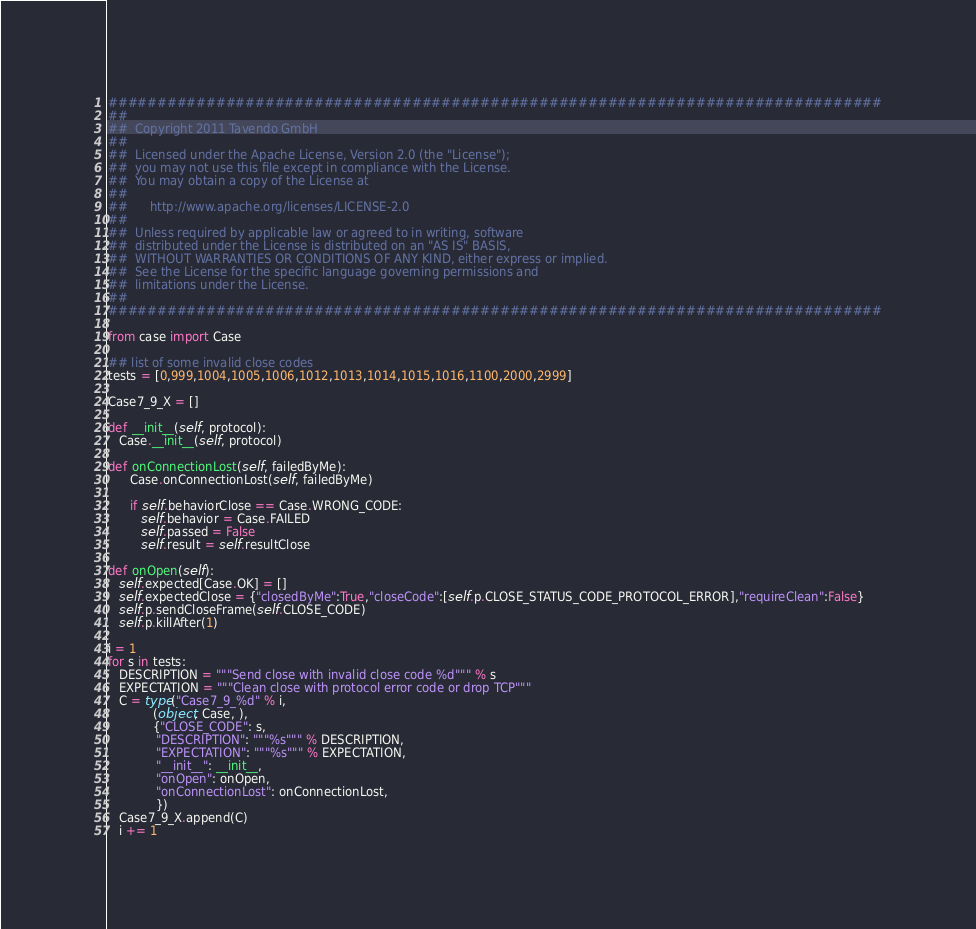Convert code to text. <code><loc_0><loc_0><loc_500><loc_500><_Python_>###############################################################################
##
##  Copyright 2011 Tavendo GmbH
##
##  Licensed under the Apache License, Version 2.0 (the "License");
##  you may not use this file except in compliance with the License.
##  You may obtain a copy of the License at
##
##      http://www.apache.org/licenses/LICENSE-2.0
##
##  Unless required by applicable law or agreed to in writing, software
##  distributed under the License is distributed on an "AS IS" BASIS,
##  WITHOUT WARRANTIES OR CONDITIONS OF ANY KIND, either express or implied.
##  See the License for the specific language governing permissions and
##  limitations under the License.
##
###############################################################################

from case import Case

## list of some invalid close codes
tests = [0,999,1004,1005,1006,1012,1013,1014,1015,1016,1100,2000,2999]

Case7_9_X = []

def __init__(self, protocol):
   Case.__init__(self, protocol)

def onConnectionLost(self, failedByMe):
      Case.onConnectionLost(self, failedByMe)

      if self.behaviorClose == Case.WRONG_CODE:
         self.behavior = Case.FAILED
         self.passed = False
         self.result = self.resultClose

def onOpen(self):
   self.expected[Case.OK] = []
   self.expectedClose = {"closedByMe":True,"closeCode":[self.p.CLOSE_STATUS_CODE_PROTOCOL_ERROR],"requireClean":False}
   self.p.sendCloseFrame(self.CLOSE_CODE)
   self.p.killAfter(1)

i = 1
for s in tests:
   DESCRIPTION = """Send close with invalid close code %d""" % s
   EXPECTATION = """Clean close with protocol error code or drop TCP"""
   C = type("Case7_9_%d" % i,
            (object, Case, ),
            {"CLOSE_CODE": s,
             "DESCRIPTION": """%s""" % DESCRIPTION,
             "EXPECTATION": """%s""" % EXPECTATION,
             "__init__": __init__,
             "onOpen": onOpen,
             "onConnectionLost": onConnectionLost,
             })
   Case7_9_X.append(C)
   i += 1
</code> 